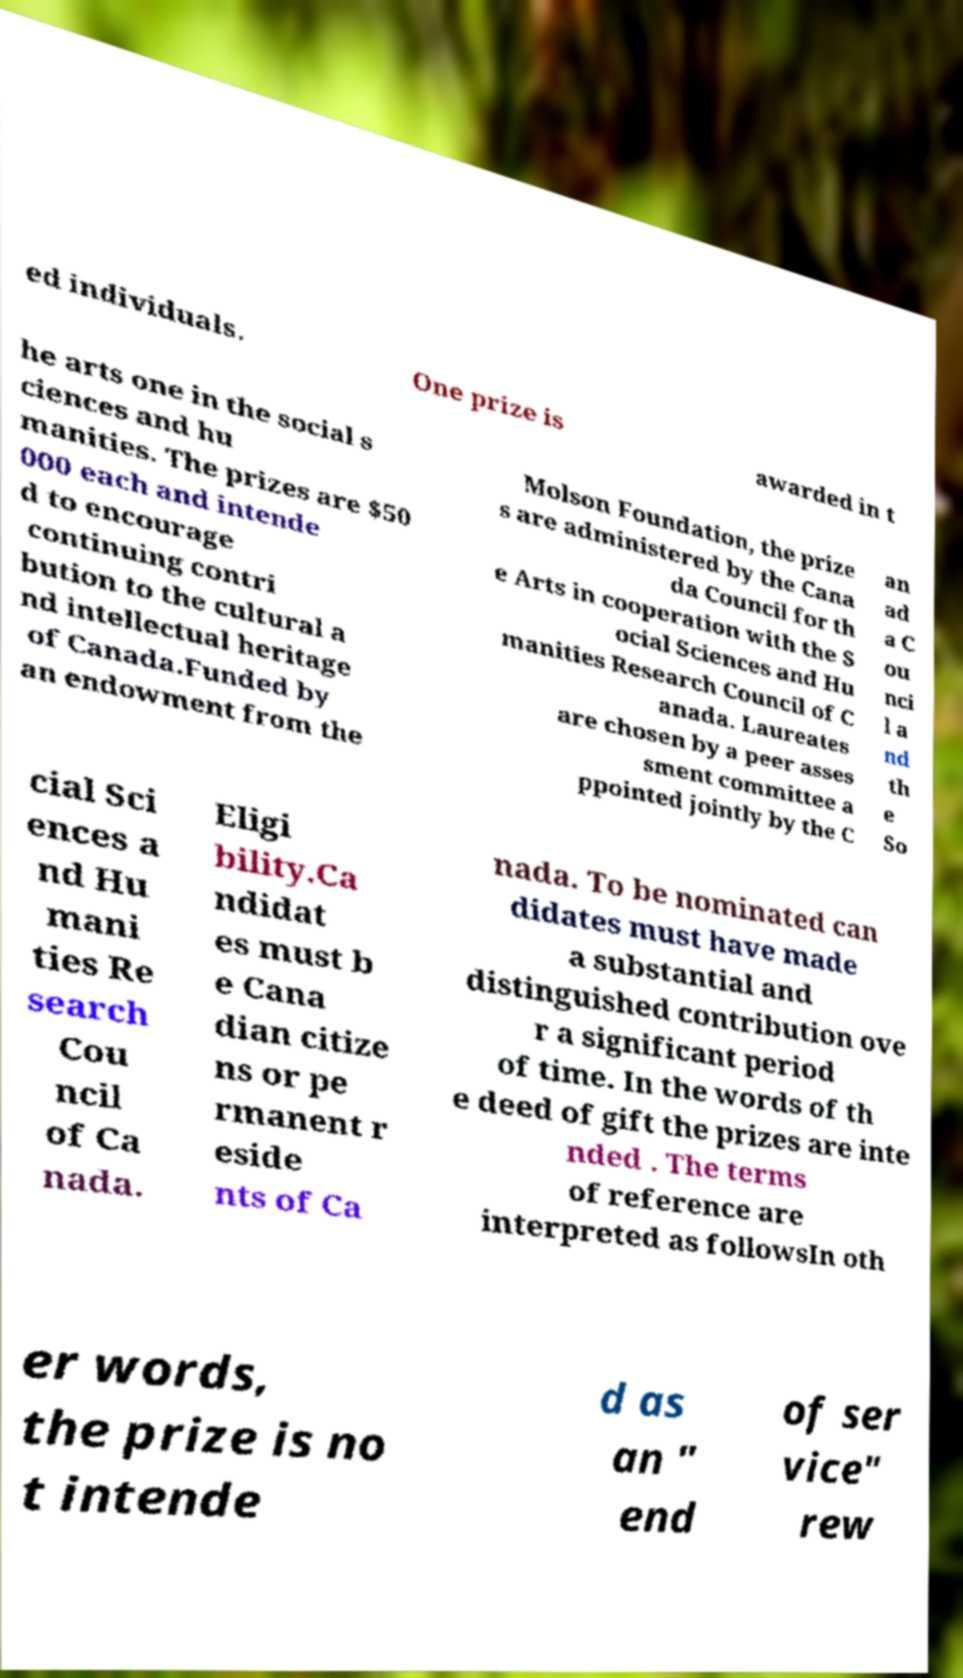For documentation purposes, I need the text within this image transcribed. Could you provide that? ed individuals. One prize is awarded in t he arts one in the social s ciences and hu manities. The prizes are $50 000 each and intende d to encourage continuing contri bution to the cultural a nd intellectual heritage of Canada.Funded by an endowment from the Molson Foundation, the prize s are administered by the Cana da Council for th e Arts in cooperation with the S ocial Sciences and Hu manities Research Council of C anada. Laureates are chosen by a peer asses sment committee a ppointed jointly by the C an ad a C ou nci l a nd th e So cial Sci ences a nd Hu mani ties Re search Cou ncil of Ca nada. Eligi bility.Ca ndidat es must b e Cana dian citize ns or pe rmanent r eside nts of Ca nada. To be nominated can didates must have made a substantial and distinguished contribution ove r a significant period of time. In the words of th e deed of gift the prizes are inte nded . The terms of reference are interpreted as followsIn oth er words, the prize is no t intende d as an " end of ser vice" rew 